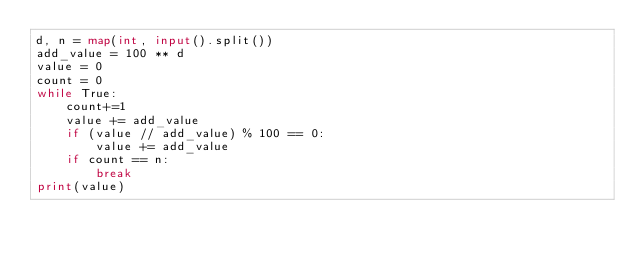<code> <loc_0><loc_0><loc_500><loc_500><_Python_>d, n = map(int, input().split())
add_value = 100 ** d
value = 0
count = 0
while True:
    count+=1
    value += add_value
    if (value // add_value) % 100 == 0:
        value += add_value
    if count == n:
        break
print(value)</code> 